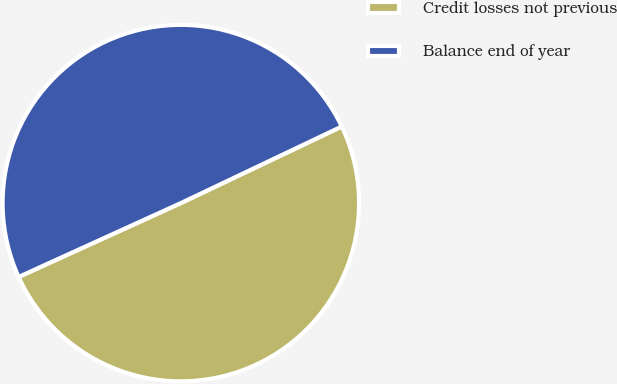Convert chart to OTSL. <chart><loc_0><loc_0><loc_500><loc_500><pie_chart><fcel>Credit losses not previous<fcel>Balance end of year<nl><fcel>50.27%<fcel>49.73%<nl></chart> 